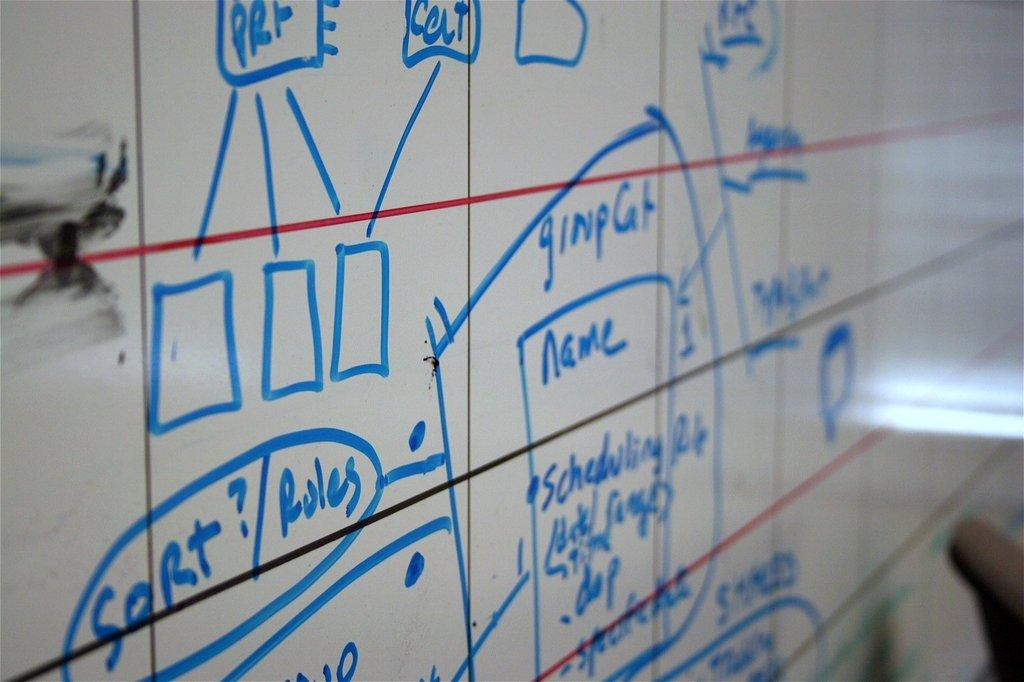<image>
Summarize the visual content of the image. A white board has writing on it including the word sort in blue. 